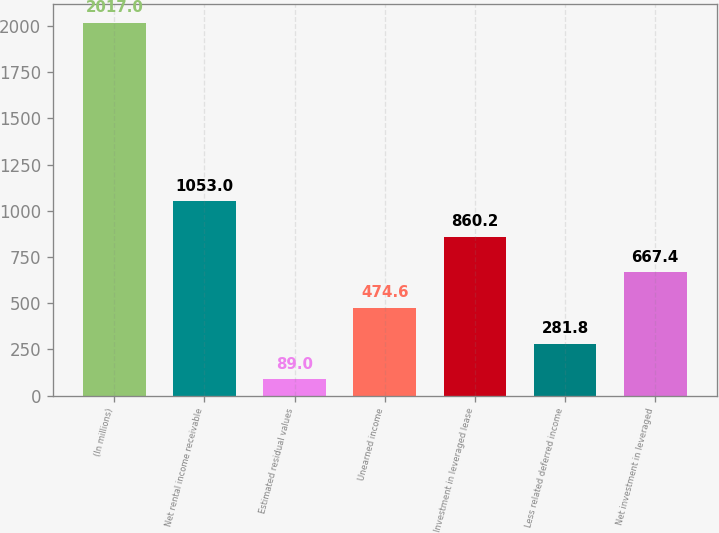<chart> <loc_0><loc_0><loc_500><loc_500><bar_chart><fcel>(In millions)<fcel>Net rental income receivable<fcel>Estimated residual values<fcel>Unearned income<fcel>Investment in leveraged lease<fcel>Less related deferred income<fcel>Net investment in leveraged<nl><fcel>2017<fcel>1053<fcel>89<fcel>474.6<fcel>860.2<fcel>281.8<fcel>667.4<nl></chart> 